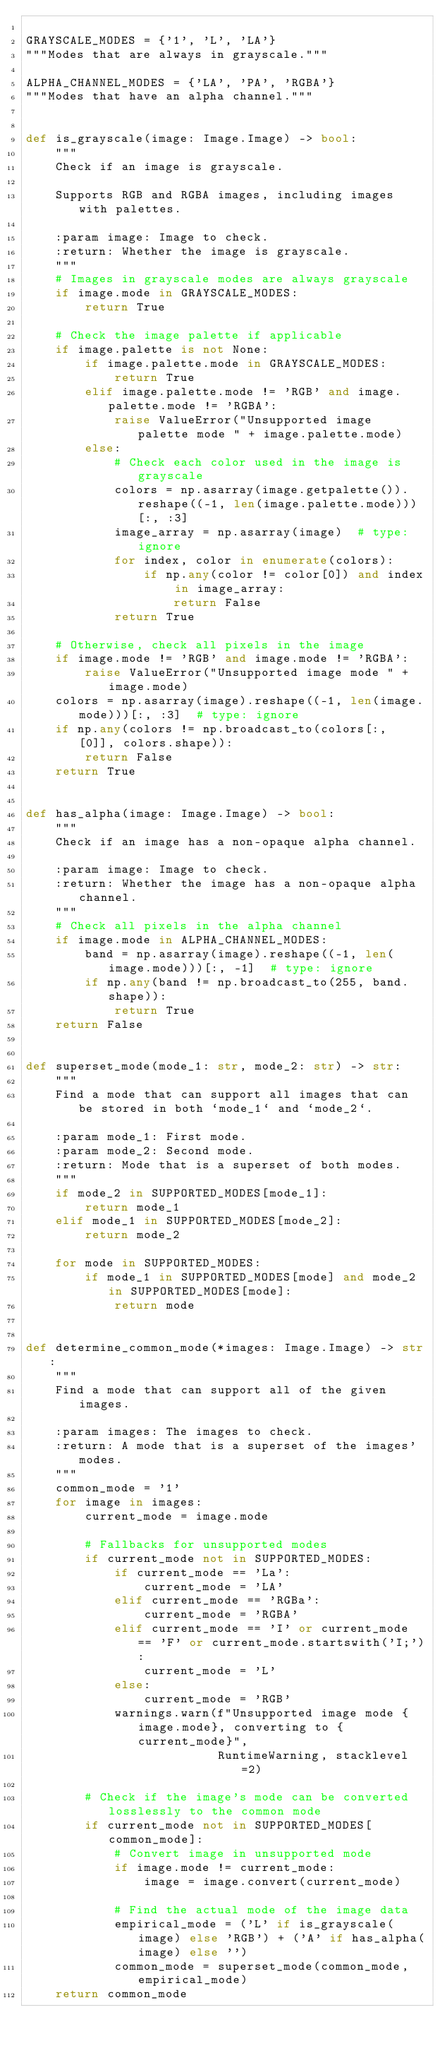Convert code to text. <code><loc_0><loc_0><loc_500><loc_500><_Python_>
GRAYSCALE_MODES = {'1', 'L', 'LA'}
"""Modes that are always in grayscale."""

ALPHA_CHANNEL_MODES = {'LA', 'PA', 'RGBA'}
"""Modes that have an alpha channel."""


def is_grayscale(image: Image.Image) -> bool:
    """
    Check if an image is grayscale.

    Supports RGB and RGBA images, including images with palettes.

    :param image: Image to check.
    :return: Whether the image is grayscale.
    """
    # Images in grayscale modes are always grayscale
    if image.mode in GRAYSCALE_MODES:
        return True

    # Check the image palette if applicable
    if image.palette is not None:
        if image.palette.mode in GRAYSCALE_MODES:
            return True
        elif image.palette.mode != 'RGB' and image.palette.mode != 'RGBA':
            raise ValueError("Unsupported image palette mode " + image.palette.mode)
        else:
            # Check each color used in the image is grayscale
            colors = np.asarray(image.getpalette()).reshape((-1, len(image.palette.mode)))[:, :3]
            image_array = np.asarray(image)  # type: ignore
            for index, color in enumerate(colors):
                if np.any(color != color[0]) and index in image_array:
                    return False
            return True

    # Otherwise, check all pixels in the image
    if image.mode != 'RGB' and image.mode != 'RGBA':
        raise ValueError("Unsupported image mode " + image.mode)
    colors = np.asarray(image).reshape((-1, len(image.mode)))[:, :3]  # type: ignore
    if np.any(colors != np.broadcast_to(colors[:, [0]], colors.shape)):
        return False
    return True


def has_alpha(image: Image.Image) -> bool:
    """
    Check if an image has a non-opaque alpha channel.

    :param image: Image to check.
    :return: Whether the image has a non-opaque alpha channel.
    """
    # Check all pixels in the alpha channel
    if image.mode in ALPHA_CHANNEL_MODES:
        band = np.asarray(image).reshape((-1, len(image.mode)))[:, -1]  # type: ignore
        if np.any(band != np.broadcast_to(255, band.shape)):
            return True
    return False


def superset_mode(mode_1: str, mode_2: str) -> str:
    """
    Find a mode that can support all images that can be stored in both `mode_1` and `mode_2`.

    :param mode_1: First mode.
    :param mode_2: Second mode.
    :return: Mode that is a superset of both modes.
    """
    if mode_2 in SUPPORTED_MODES[mode_1]:
        return mode_1
    elif mode_1 in SUPPORTED_MODES[mode_2]:
        return mode_2

    for mode in SUPPORTED_MODES:
        if mode_1 in SUPPORTED_MODES[mode] and mode_2 in SUPPORTED_MODES[mode]:
            return mode


def determine_common_mode(*images: Image.Image) -> str:
    """
    Find a mode that can support all of the given images.

    :param images: The images to check.
    :return: A mode that is a superset of the images' modes.
    """
    common_mode = '1'
    for image in images:
        current_mode = image.mode

        # Fallbacks for unsupported modes
        if current_mode not in SUPPORTED_MODES:
            if current_mode == 'La':
                current_mode = 'LA'
            elif current_mode == 'RGBa':
                current_mode = 'RGBA'
            elif current_mode == 'I' or current_mode == 'F' or current_mode.startswith('I;'):
                current_mode = 'L'
            else:
                current_mode = 'RGB'
            warnings.warn(f"Unsupported image mode {image.mode}, converting to {current_mode}",
                          RuntimeWarning, stacklevel=2)

        # Check if the image's mode can be converted losslessly to the common mode
        if current_mode not in SUPPORTED_MODES[common_mode]:
            # Convert image in unsupported mode
            if image.mode != current_mode:
                image = image.convert(current_mode)

            # Find the actual mode of the image data
            empirical_mode = ('L' if is_grayscale(image) else 'RGB') + ('A' if has_alpha(image) else '')
            common_mode = superset_mode(common_mode, empirical_mode)
    return common_mode
</code> 